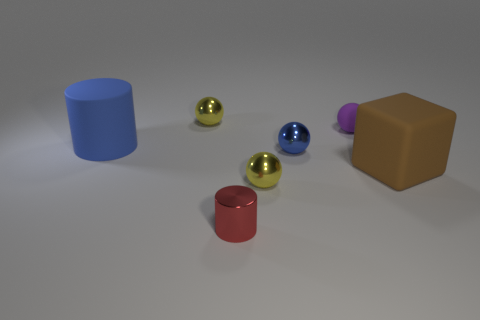The small rubber thing that is to the right of the yellow sphere behind the sphere in front of the large brown object is what color?
Keep it short and to the point. Purple. What is the shape of the thing that is on the left side of the tiny red object and right of the blue cylinder?
Your answer should be compact. Sphere. Are there any other things that have the same size as the blue cylinder?
Your answer should be very brief. Yes. There is a sphere to the left of the small metallic sphere in front of the brown thing; what is its color?
Provide a short and direct response. Yellow. There is a big matte thing that is to the right of the big blue matte cylinder behind the sphere in front of the small blue thing; what shape is it?
Make the answer very short. Cube. What is the size of the matte thing that is on the left side of the brown matte block and on the right side of the red object?
Keep it short and to the point. Small. What number of other spheres have the same color as the rubber ball?
Your answer should be very brief. 0. There is a ball that is the same color as the large rubber cylinder; what is its material?
Keep it short and to the point. Metal. What material is the big cylinder?
Give a very brief answer. Rubber. Do the cylinder that is in front of the large brown thing and the big brown object have the same material?
Ensure brevity in your answer.  No. 